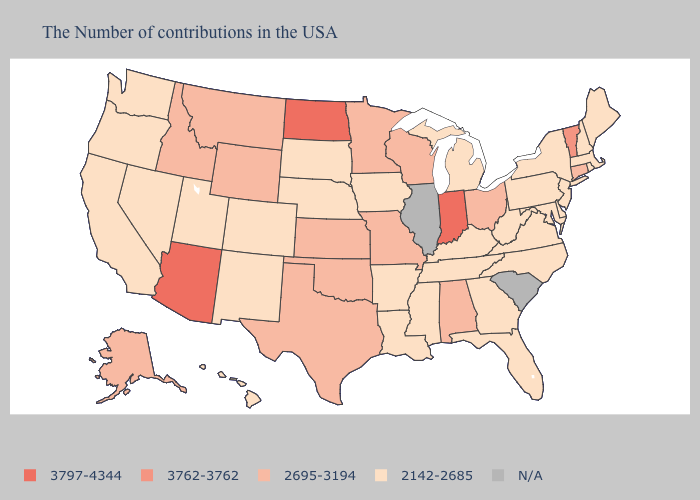Name the states that have a value in the range 2142-2685?
Concise answer only. Maine, Massachusetts, Rhode Island, New Hampshire, New York, New Jersey, Delaware, Maryland, Pennsylvania, Virginia, North Carolina, West Virginia, Florida, Georgia, Michigan, Kentucky, Tennessee, Mississippi, Louisiana, Arkansas, Iowa, Nebraska, South Dakota, Colorado, New Mexico, Utah, Nevada, California, Washington, Oregon, Hawaii. Name the states that have a value in the range N/A?
Give a very brief answer. South Carolina, Illinois. Which states hav the highest value in the South?
Keep it brief. Alabama, Oklahoma, Texas. What is the highest value in the MidWest ?
Short answer required. 3797-4344. Which states have the lowest value in the USA?
Answer briefly. Maine, Massachusetts, Rhode Island, New Hampshire, New York, New Jersey, Delaware, Maryland, Pennsylvania, Virginia, North Carolina, West Virginia, Florida, Georgia, Michigan, Kentucky, Tennessee, Mississippi, Louisiana, Arkansas, Iowa, Nebraska, South Dakota, Colorado, New Mexico, Utah, Nevada, California, Washington, Oregon, Hawaii. What is the value of Tennessee?
Write a very short answer. 2142-2685. Name the states that have a value in the range N/A?
Be succinct. South Carolina, Illinois. What is the value of Vermont?
Give a very brief answer. 3762-3762. What is the value of Iowa?
Quick response, please. 2142-2685. Is the legend a continuous bar?
Give a very brief answer. No. What is the value of New Hampshire?
Write a very short answer. 2142-2685. Does New Hampshire have the lowest value in the USA?
Answer briefly. Yes. Does Virginia have the highest value in the USA?
Be succinct. No. 